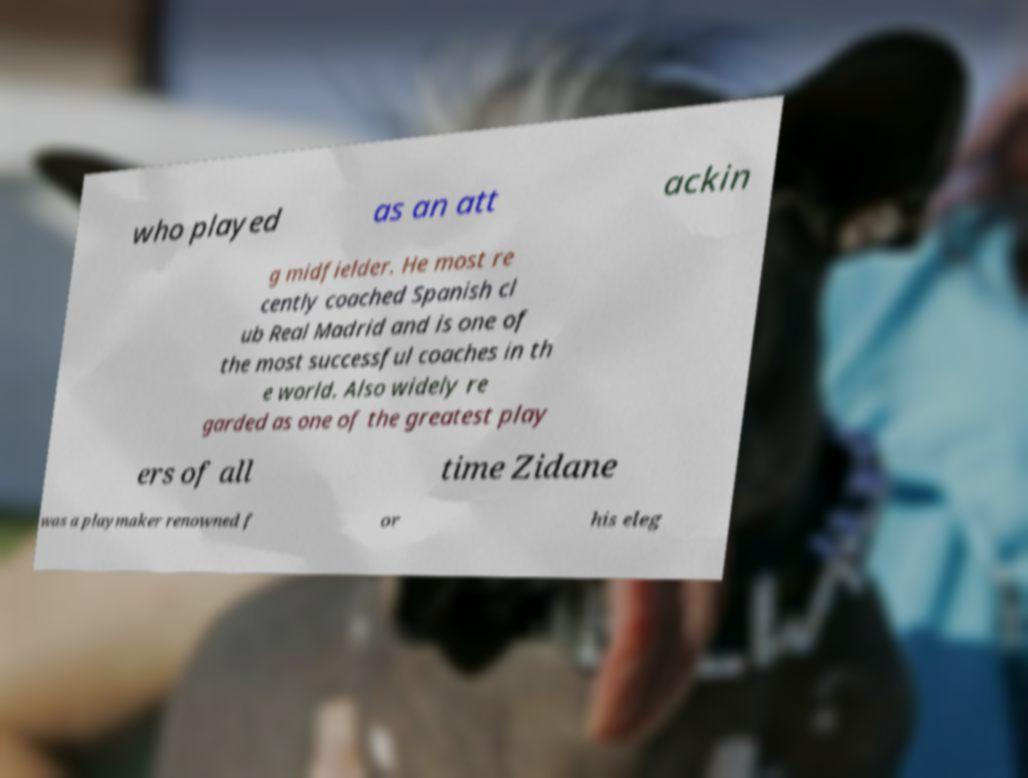Please identify and transcribe the text found in this image. who played as an att ackin g midfielder. He most re cently coached Spanish cl ub Real Madrid and is one of the most successful coaches in th e world. Also widely re garded as one of the greatest play ers of all time Zidane was a playmaker renowned f or his eleg 